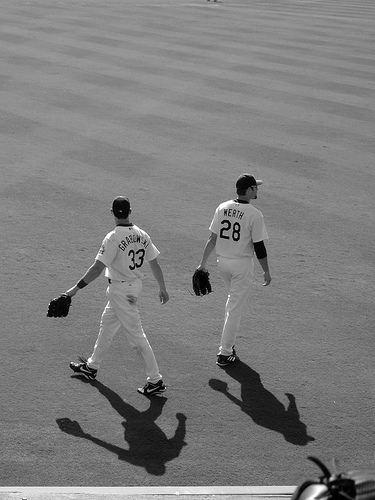How many people are in the photo? There are two people in the photo, captured from behind as they walk across what appears to be a baseball field, judging by their attire which includes jerseys and gloves. 